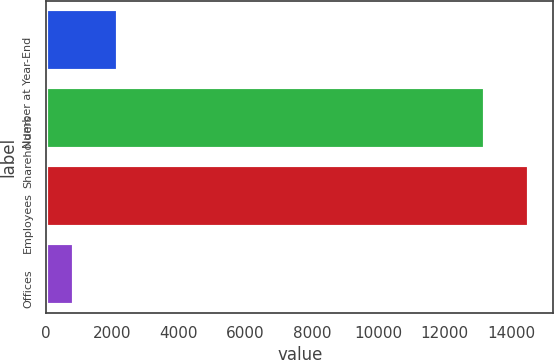Convert chart. <chart><loc_0><loc_0><loc_500><loc_500><bar_chart><fcel>Number at Year-End<fcel>Shareholders<fcel>Employees<fcel>Offices<nl><fcel>2171.4<fcel>13207<fcel>14546.4<fcel>832<nl></chart> 